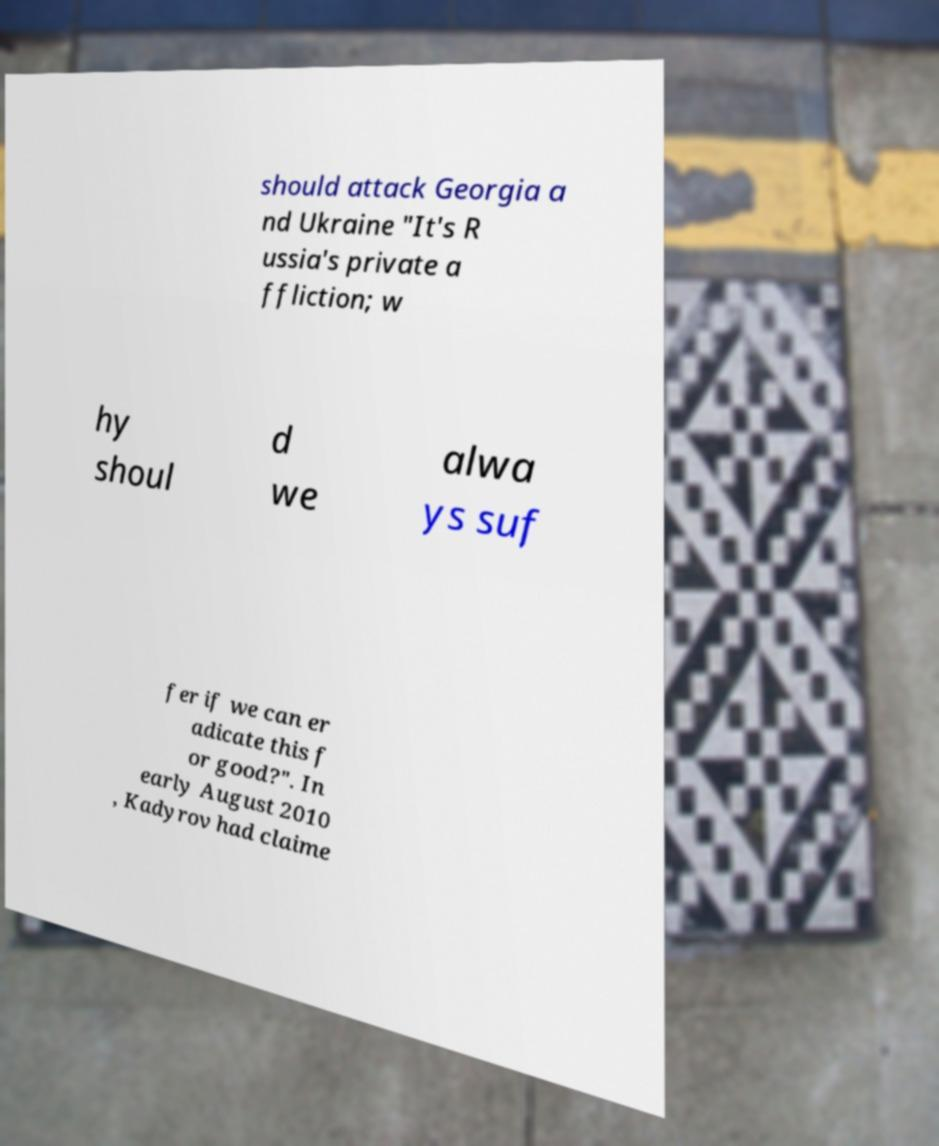Could you extract and type out the text from this image? should attack Georgia a nd Ukraine "It's R ussia's private a ffliction; w hy shoul d we alwa ys suf fer if we can er adicate this f or good?". In early August 2010 , Kadyrov had claime 